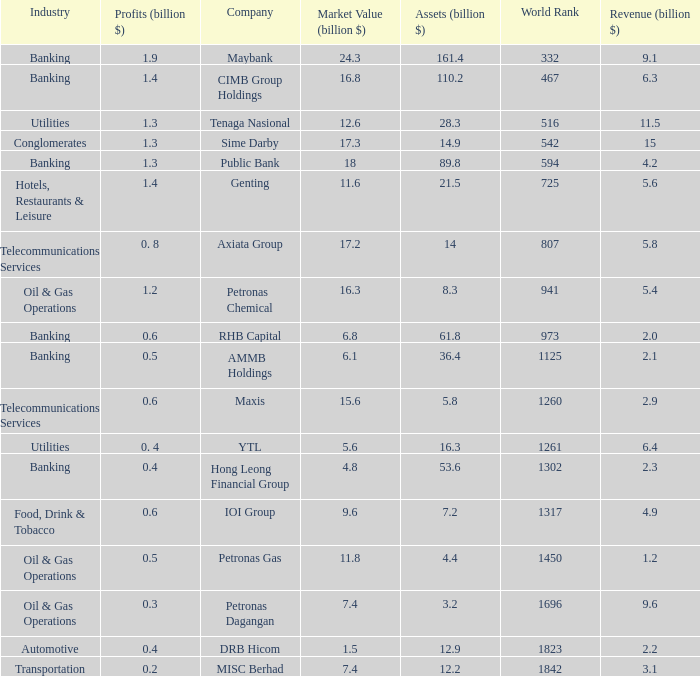Name the total number of industry for maxis 1.0. 